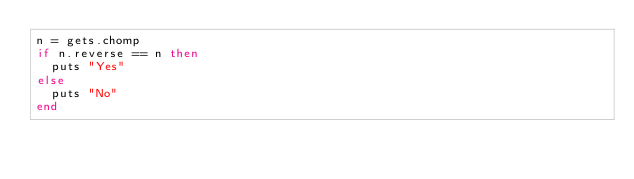<code> <loc_0><loc_0><loc_500><loc_500><_Ruby_>n = gets.chomp
if n.reverse == n then
  puts "Yes"
else
  puts "No"
end</code> 